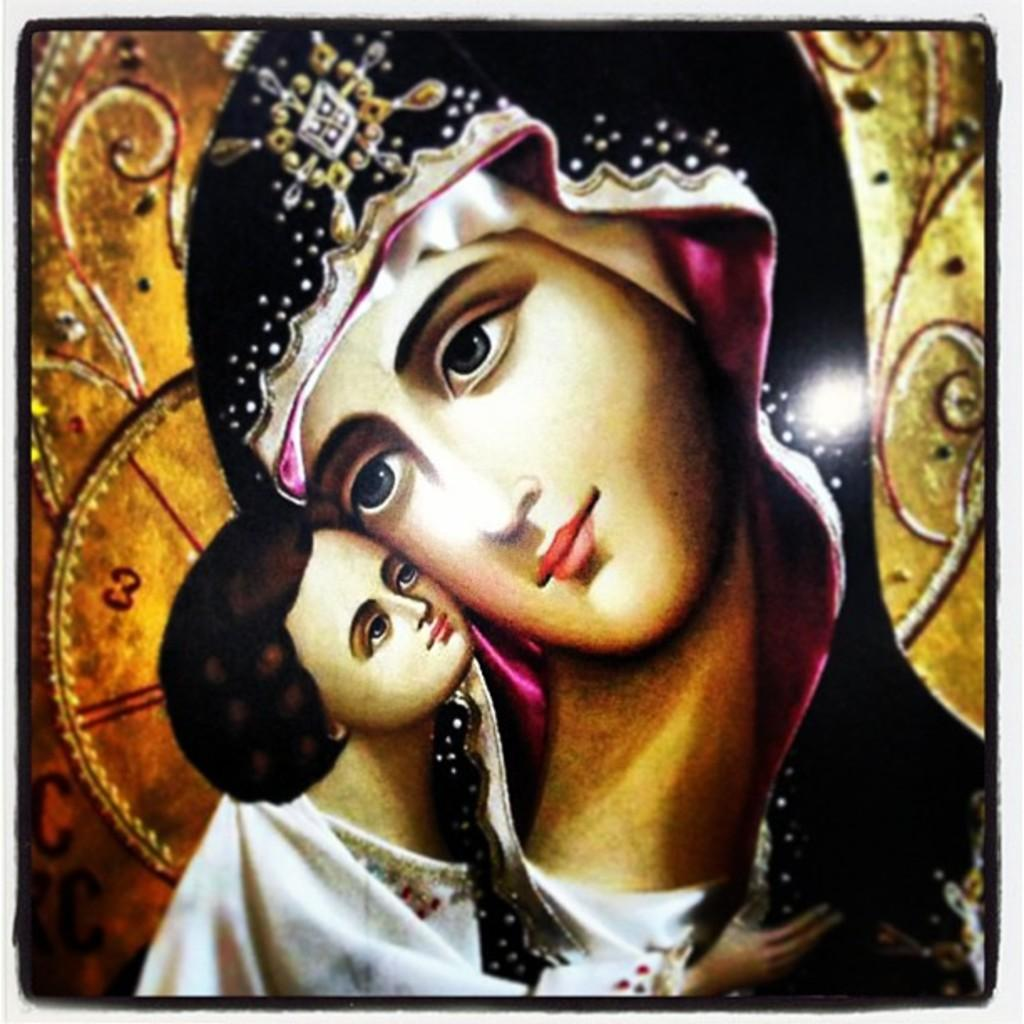What is featured on the poster in the image? There is a poster in the image, and it contains a painting. What is the subject matter of the painting on the poster? The painting depicts two people. What is the purpose of the finger in the painting on the poster? There is no finger present in the painting on the poster; it depicts two people. 